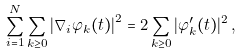<formula> <loc_0><loc_0><loc_500><loc_500>\sum _ { i = 1 } ^ { N } \sum _ { k \geq 0 } \left | \nabla _ { i } \varphi _ { k } ( t ) \right | ^ { 2 } = 2 \sum _ { k \geq 0 } | \varphi _ { k } ^ { \prime } ( t ) | ^ { 2 } \, ,</formula> 